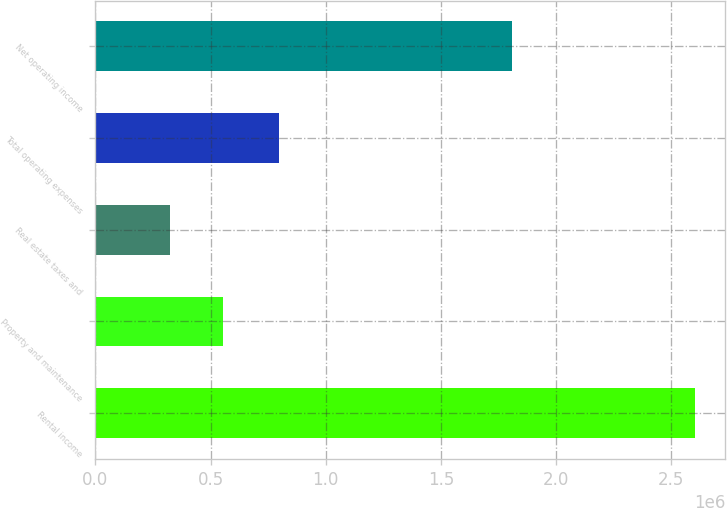<chart> <loc_0><loc_0><loc_500><loc_500><bar_chart><fcel>Rental income<fcel>Property and maintenance<fcel>Real estate taxes and<fcel>Total operating expenses<fcel>Net operating income<nl><fcel>2.60531e+06<fcel>553392<fcel>325401<fcel>798499<fcel>1.80681e+06<nl></chart> 